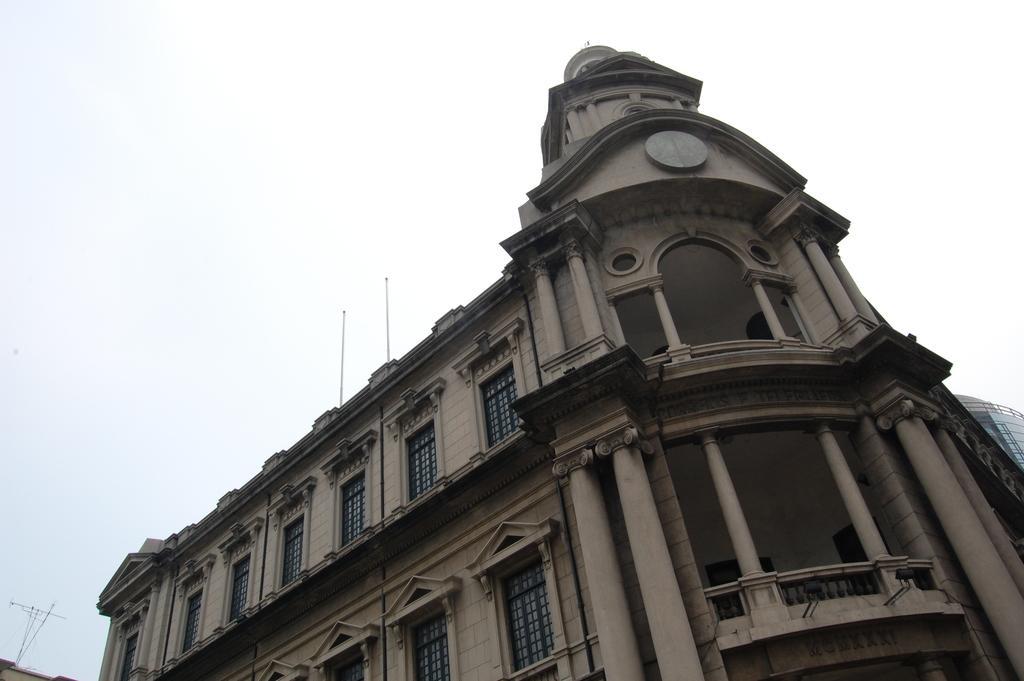How would you summarize this image in a sentence or two? This picture is clicked outside. In the center we can see a building and we can see the windows, pillars and the railing of the building. In the background we can see the sky and some other objects. 